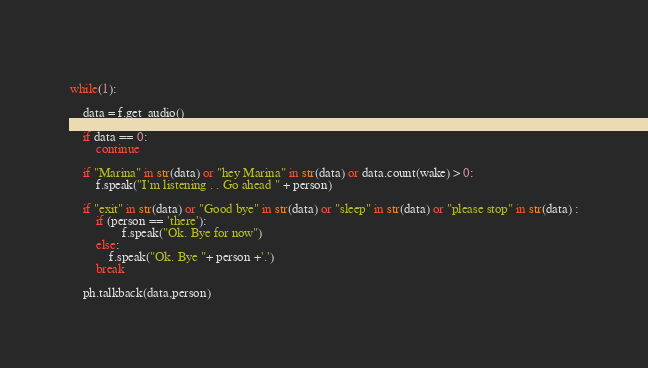<code> <loc_0><loc_0><loc_500><loc_500><_Python_>    
while(1): 
    
    data = f.get_audio()
    
    if data == 0: 
        continue

    if "Marina" in str(data) or "hey Marina" in str(data) or data.count(wake) > 0:
        f.speak("I'm listening . . Go ahead " + person)
                   
    if "exit" in str(data) or "Good bye" in str(data) or "sleep" in str(data) or "please stop" in str(data) :
        if (person == 'there'):
                f.speak("Ok. Bye for now")
        else:
            f.speak("Ok. Bye "+ person +'.')
        break       
    
    ph.talkback(data,person)

</code> 